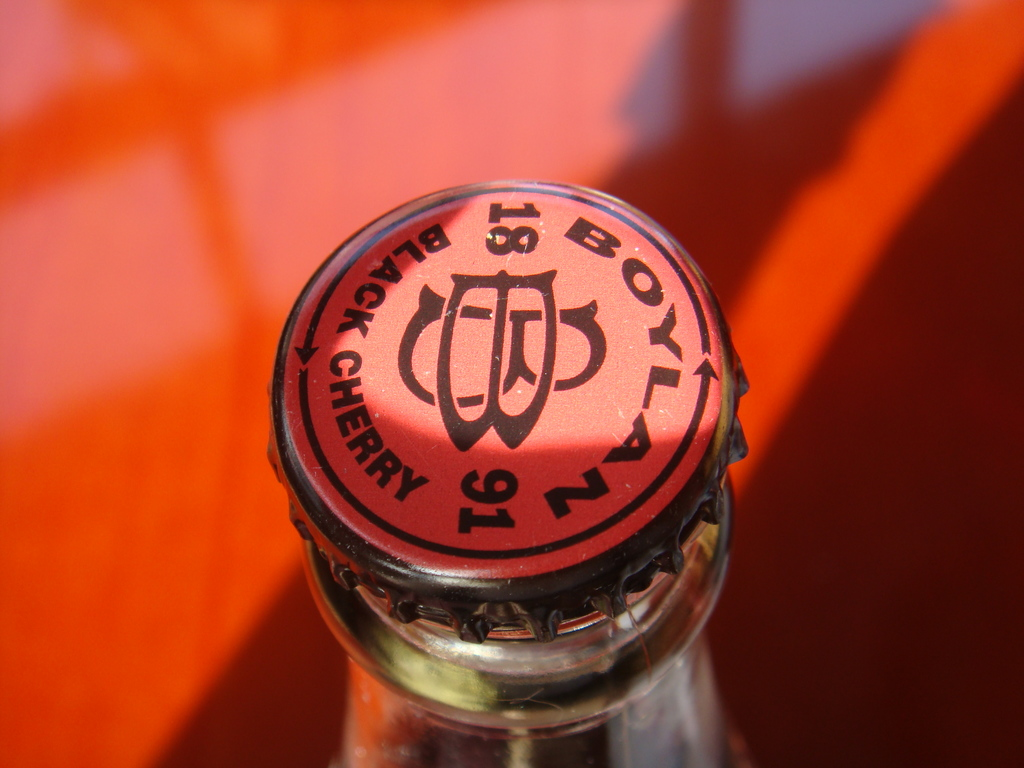What does the 'BOWL 91' text on the bottle cap signify? The 'BOWL 91' text could represent a brand name or a specific line of products. It might also suggest a commemorative edition, perhaps linked to an event in the year 1991, or it could simply be a creative marketing tactic to evoke a sense of nostalgia or exclusivity. 